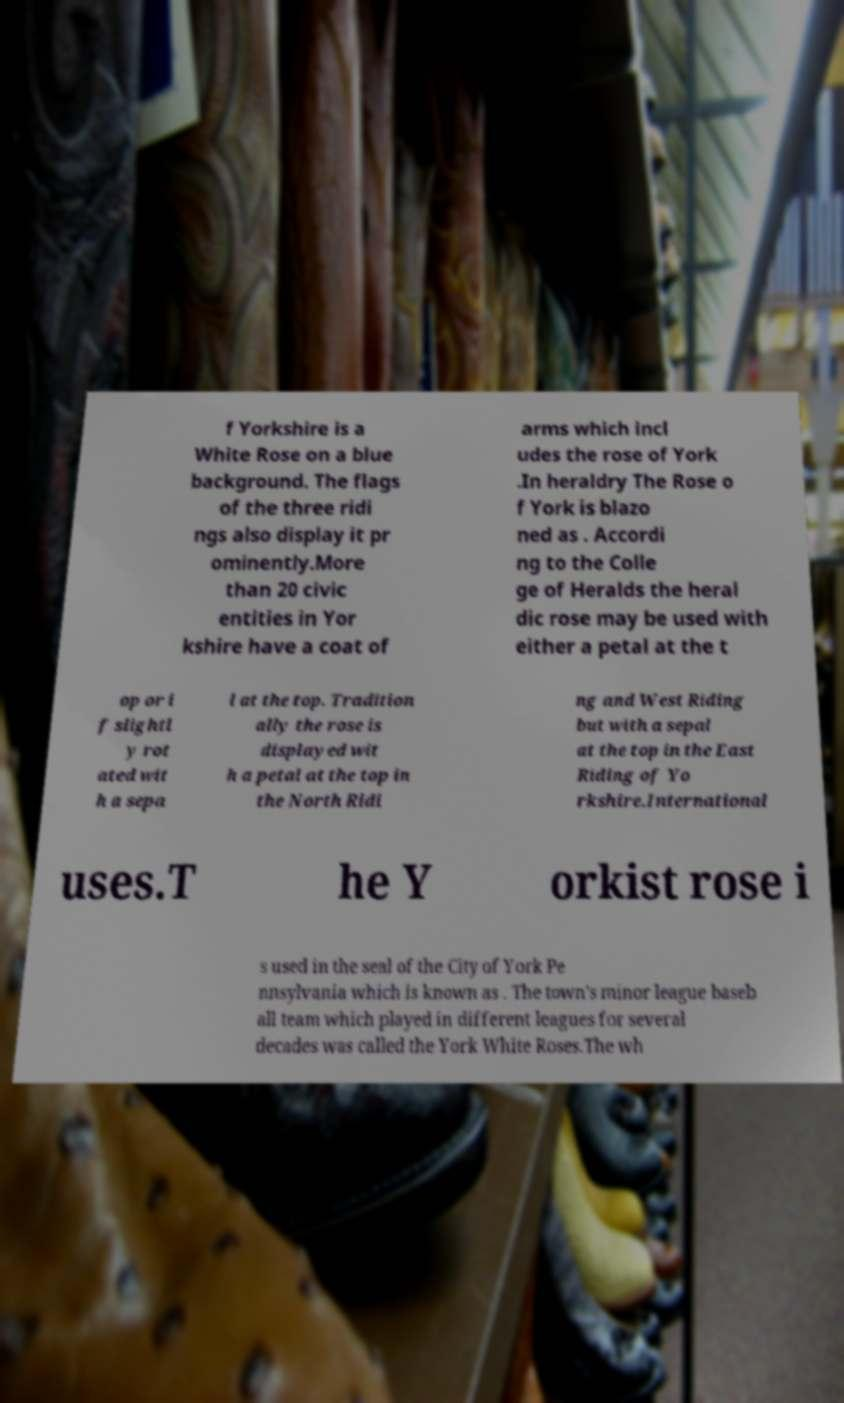There's text embedded in this image that I need extracted. Can you transcribe it verbatim? f Yorkshire is a White Rose on a blue background. The flags of the three ridi ngs also display it pr ominently.More than 20 civic entities in Yor kshire have a coat of arms which incl udes the rose of York .In heraldry The Rose o f York is blazo ned as . Accordi ng to the Colle ge of Heralds the heral dic rose may be used with either a petal at the t op or i f slightl y rot ated wit h a sepa l at the top. Tradition ally the rose is displayed wit h a petal at the top in the North Ridi ng and West Riding but with a sepal at the top in the East Riding of Yo rkshire.International uses.T he Y orkist rose i s used in the seal of the City of York Pe nnsylvania which is known as . The town's minor league baseb all team which played in different leagues for several decades was called the York White Roses.The wh 